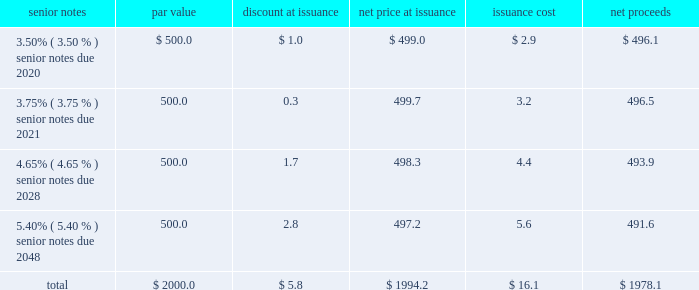Notes to consolidated financial statements 2013 ( continued ) ( amounts in millions , except per share amounts ) debt transactions see note 6 for further information regarding the company 2019s acquisition of acxiom ( the 201cacxiom acquisition 201d ) on october 1 , 2018 ( the 201cclosing date 201d ) .
Senior notes on september 21 , 2018 , in order to fund the acxiom acquisition and related fees and expenses , we issued a total of $ 2000.0 in aggregate principal amount of unsecured senior notes ( in four separate series of $ 500.0 each , together , the 201csenior notes 201d ) .
Upon issuance , the senior notes were reflected on our consolidated balance sheets net of discount of $ 5.8 and net of the capitalized debt issuance costs , including commissions and offering expenses of $ 16.1 , both of which will be amortized in interest expense through the respective maturity dates of each series of senior notes using the effective interest method .
Interest is payable semi-annually in arrears on april 1st and october 1st of each year , commencing on april 1 , 2019 .
The issuance was comprised of the following four series of notes : senior notes par value discount at issuance net price at issuance issuance cost net proceeds .
Consistent with our other debt securities , the newly issued senior notes include covenants that , among other things , limit our liens and the liens of certain of our consolidated subsidiaries , but do not require us to maintain any financial ratios or specified levels of net worth or liquidity .
We may redeem each series of the senior notes at any time in whole or from time to time in part in accordance with the provisions of the indenture , including the applicable supplemental indenture , under which such series of senior notes was issued .
If the acxiom acquisition had been terminated or had not closed on or prior to june 30 , 2019 , we would have been required to redeem the senior notes due 2020 , 2021 and 2028 at a redemption price equal to 101% ( 101 % ) of the principal amount thereof , plus accrued and unpaid interest .
Additionally , upon the occurrence of a change of control repurchase event with respect to the senior notes , each holder of the senior notes has the right to require the company to purchase that holder 2019s senior notes at a price equal to 101% ( 101 % ) of the principal amount thereof , plus accrued and unpaid interest , unless the company has exercised its option to redeem all the senior notes .
Term loan agreement on october 1 , 2018 , in order to fund the acxiom acquisition and related fees and expenses , we borrowed $ 500.0 through debt financing arrangements with third-party lenders under a three-year term loan agreement ( the 201cterm loan agreement 201d ) , $ 100.0 of which we paid down on december 3 , 2018 .
Consistent with our other debt securities , the term loan agreement includes covenants that , among other things , limit our liens and the liens of certain of our consolidated subsidiaries .
In addition , it requires us to maintain the same financial maintenance covenants as discussed below .
Loans under the term loan bear interest at a variable rate based on , at the company 2019s option , either the base rate or the eurodollar rate ( each as defined in the term loan agreement ) plus an applicable margin that is determined based on our credit ratings .
As of december 31 , 2018 , the applicable margin was 0.25% ( 0.25 % ) for base rate loans and 1.25% ( 1.25 % ) for eurodollar rate loans. .
What was the ratio of the issuance costs to the discount at issuance? 
Computations: (16.1 / 5.8)
Answer: 2.77586. 